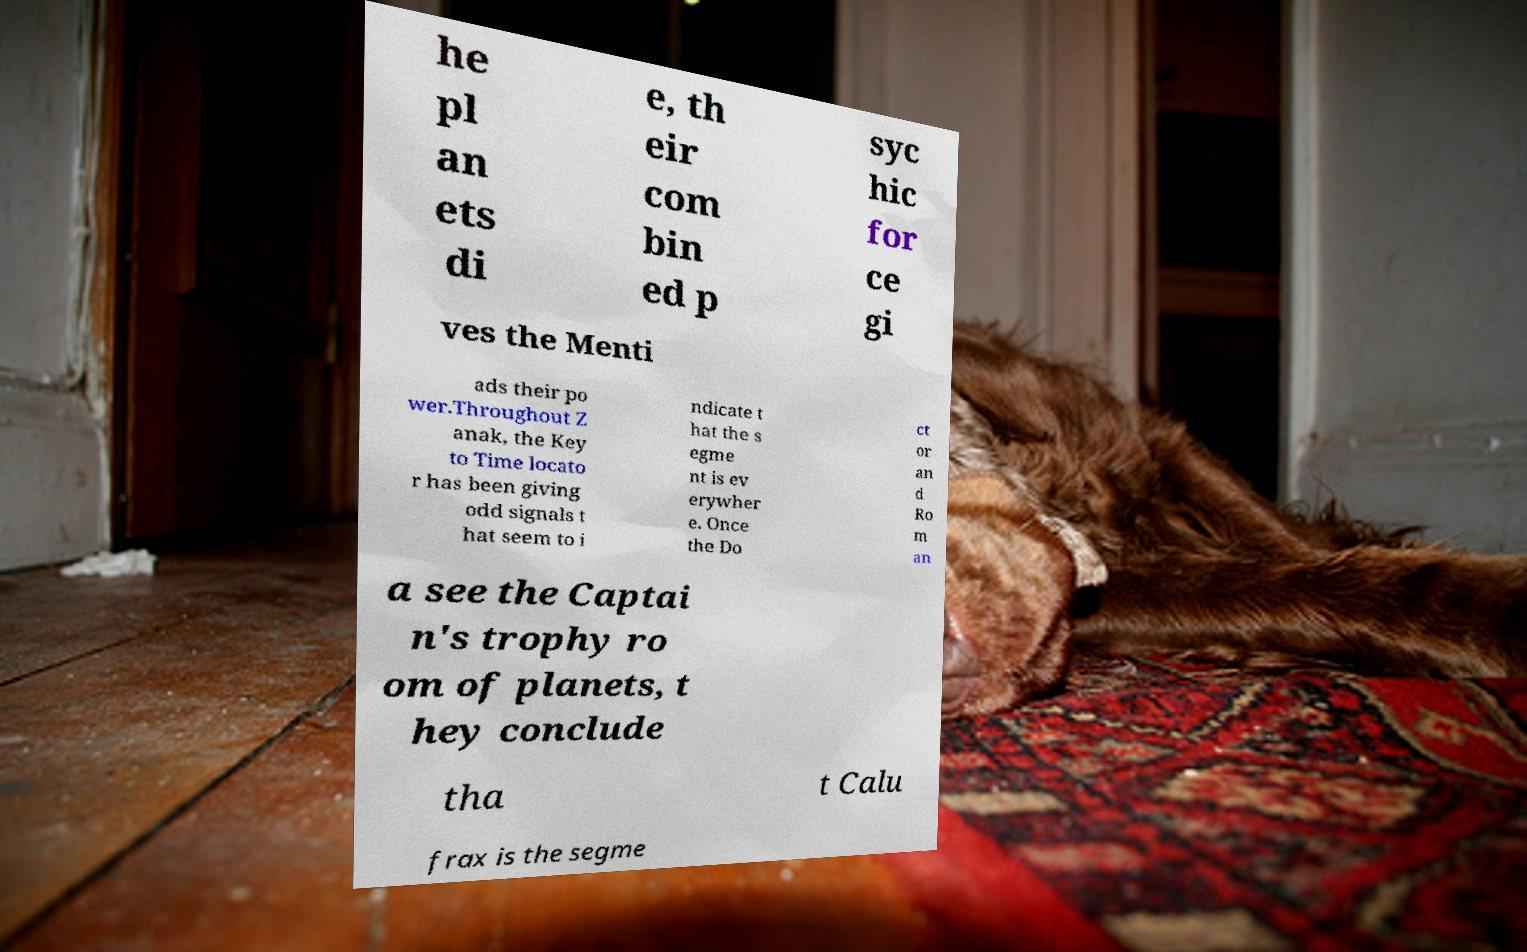Please identify and transcribe the text found in this image. he pl an ets di e, th eir com bin ed p syc hic for ce gi ves the Menti ads their po wer.Throughout Z anak, the Key to Time locato r has been giving odd signals t hat seem to i ndicate t hat the s egme nt is ev erywher e. Once the Do ct or an d Ro m an a see the Captai n's trophy ro om of planets, t hey conclude tha t Calu frax is the segme 